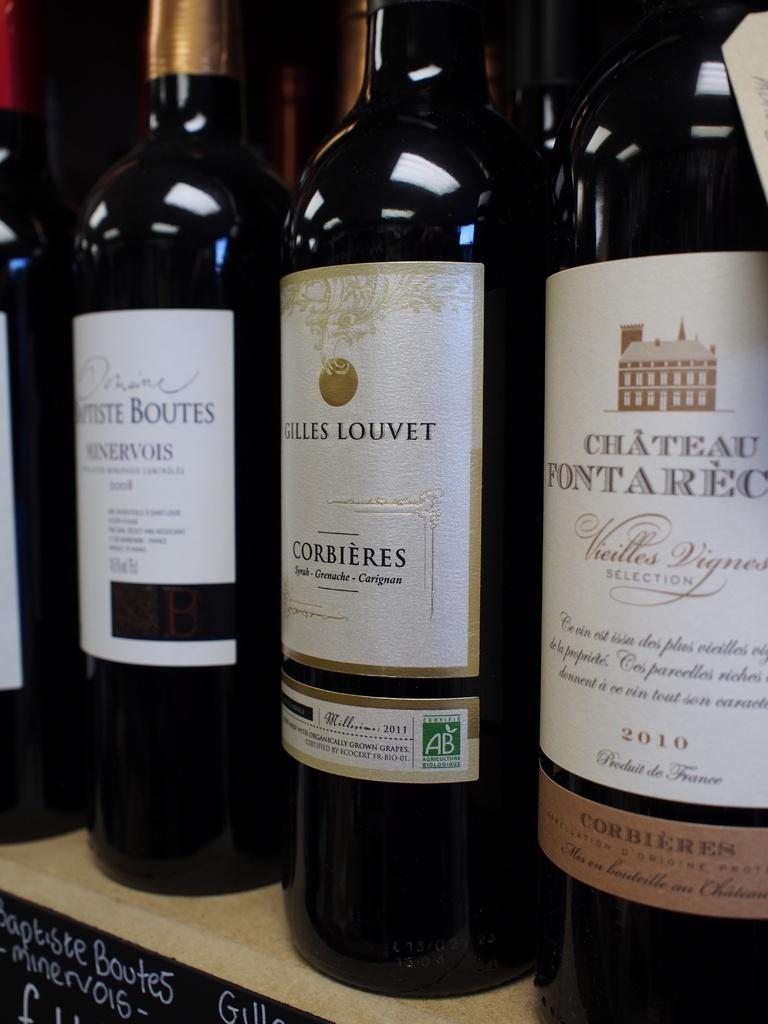<image>
Give a short and clear explanation of the subsequent image. A bottle of Gilles Louvet wine has a green logo on the label that says AB. 